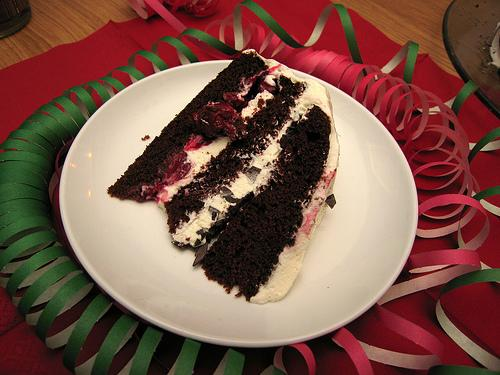Provide a brief description of the prominent objects in the image. Two white people stand in front of a giraffe, a cake with white and brown frosting sits atop a plate, and various colored ribbons are scattered around. Summarize the image in a tweet. Party time!🥳 Two peeps chillin' with a #Giraffe🦒 and a delish white-brown frosted #cake🍰 surrounded by vibrant ribbons. #PartyVibes Write a sentence that combines the people, the cake, and the ribbons present in the image. At a whimsical gathering, two people share a moment near a giraffe while a white and brown frosted cake sits on a plate surrounded by colorful ribbons. Write a headline that would best summarize the content of the image. A Festive Party with Two People, Giraffe, and Tasty Cake Give a quick overview of the image, mentioning key elements without going into too much detail. Two people stand near a giraffe, there's a cake on a plate, and various colored ribbons are present. Mention the main actions and items featured in the image using simple language. People are standing near a giraffe, there is a cake on a plate, and many ribbons in different colors can be seen. Describe the most noteworthy subject in the image and the elements that surround it. A duo of white individuals stands by a giraffe as a white and brown frosted cake makes a delicious centerpiece, with various colored ribbons decorating the scene. Enumerate the main elements featured within the image. 5. Assorted colored ribbons Narrate a scene you observe from the details provided in the image. At a party decorated with colorful ribbons, two people stand beside a giraffe while a delicious-looking cake with white and brown icing awaits nearby on a plate. Describe the essential components of the image using formal language. The image primarily consists of two Caucasian individuals positioned in front of a giraffe, a dessert plated on the table displaying white and brown frosting, as well as several ribbons situated all around. 